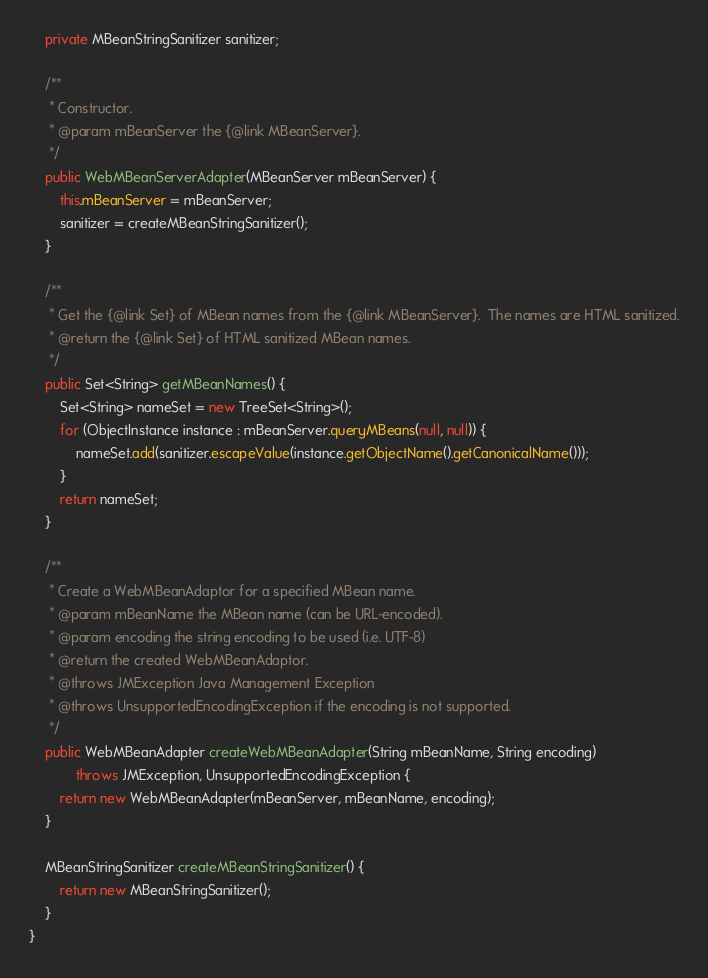Convert code to text. <code><loc_0><loc_0><loc_500><loc_500><_Java_>
    private MBeanStringSanitizer sanitizer;

    /**
     * Constructor.
     * @param mBeanServer the {@link MBeanServer}.
     */
    public WebMBeanServerAdapter(MBeanServer mBeanServer) {
        this.mBeanServer = mBeanServer;
        sanitizer = createMBeanStringSanitizer();
    }

    /**
     * Get the {@link Set} of MBean names from the {@link MBeanServer}.  The names are HTML sanitized.
     * @return the {@link Set} of HTML sanitized MBean names.
     */
    public Set<String> getMBeanNames() {
        Set<String> nameSet = new TreeSet<String>();
        for (ObjectInstance instance : mBeanServer.queryMBeans(null, null)) {
            nameSet.add(sanitizer.escapeValue(instance.getObjectName().getCanonicalName()));
        }
        return nameSet;
    }

    /**
     * Create a WebMBeanAdaptor for a specified MBean name.
     * @param mBeanName the MBean name (can be URL-encoded).
     * @param encoding the string encoding to be used (i.e. UTF-8)
     * @return the created WebMBeanAdaptor.
     * @throws JMException Java Management Exception
     * @throws UnsupportedEncodingException if the encoding is not supported.
     */
    public WebMBeanAdapter createWebMBeanAdapter(String mBeanName, String encoding)
            throws JMException, UnsupportedEncodingException {
        return new WebMBeanAdapter(mBeanServer, mBeanName, encoding);
    }

    MBeanStringSanitizer createMBeanStringSanitizer() {
        return new MBeanStringSanitizer();
    }
}
</code> 